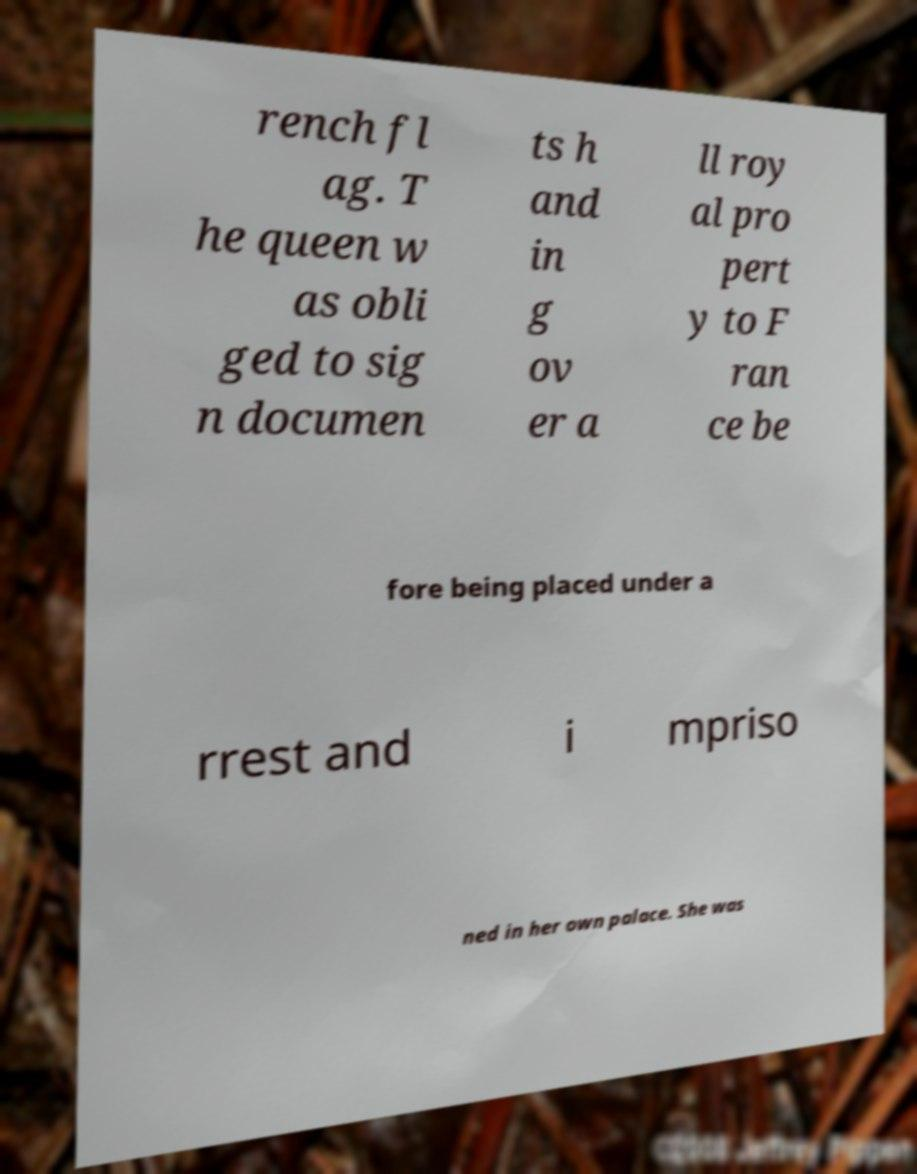Could you assist in decoding the text presented in this image and type it out clearly? rench fl ag. T he queen w as obli ged to sig n documen ts h and in g ov er a ll roy al pro pert y to F ran ce be fore being placed under a rrest and i mpriso ned in her own palace. She was 